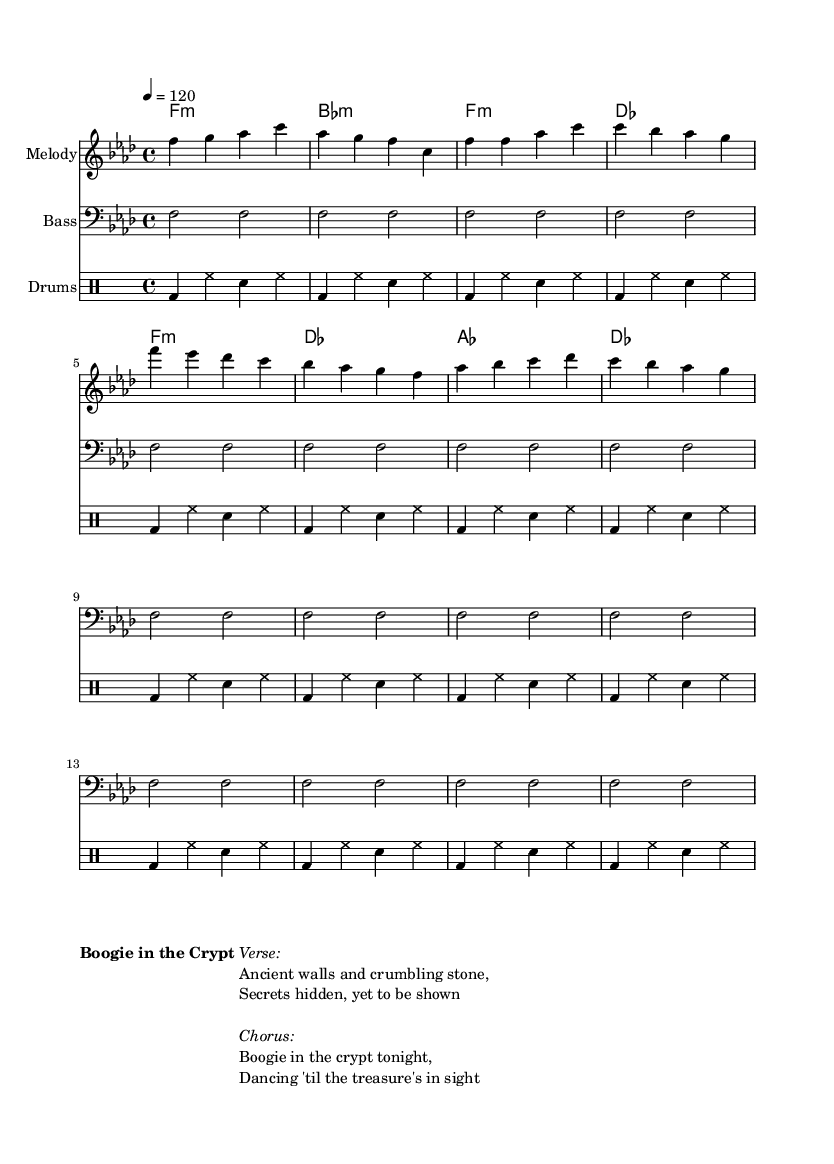What is the key signature of this music? The key signature is F minor, which has four flats (B♭, E♭, A♭, and D♭). This can be determined by looking at the key signature at the beginning of the score, which is indicated in the global section of the code.
Answer: F minor What is the time signature of this music? The time signature is 4/4, which indicates that there are four beats per measure and a quarter note receives one beat. This information is located in the global section of the code.
Answer: 4/4 What is the tempo marking of this music? The tempo marking is quarter note equals 120. This is specified in the global section of the code where the tempo is set. It means the piece should be played at a speed of 120 quarter notes per minute.
Answer: 120 How many measures are in the melody section? The melody section consists of 12 measures. By counting the measures in the melody portion of the code, we see there are 12 groups concatenated.
Answer: 12 What is the main lyrical theme of the song? The main lyrical theme is about hidden treasures and ancient mysteries, as indicated by the lines in the verse and chorus. The verse refers to "ancient walls and crumbling stone," while the chorus talks about "Dancing 'til the treasure's in sight."
Answer: Hidden treasures What instruments are featured in this piece? The piece features a melody staff, a bass staff, and a drum staff. Each instrument's part is listed in the score section with their respective names: "Melody," "Bass," and "Drums."
Answer: Melody, Bass, Drums What type of rhythms are used in the drum part? The drum part primarily uses a steady bass drum (bd), hi-hat (hh), and snare drum (sn) rhythm pattern repeated in a simple four-beat structure. This consistent rhythm is common in disco music, emphasizing the danceable groove.
Answer: Steady patterns 